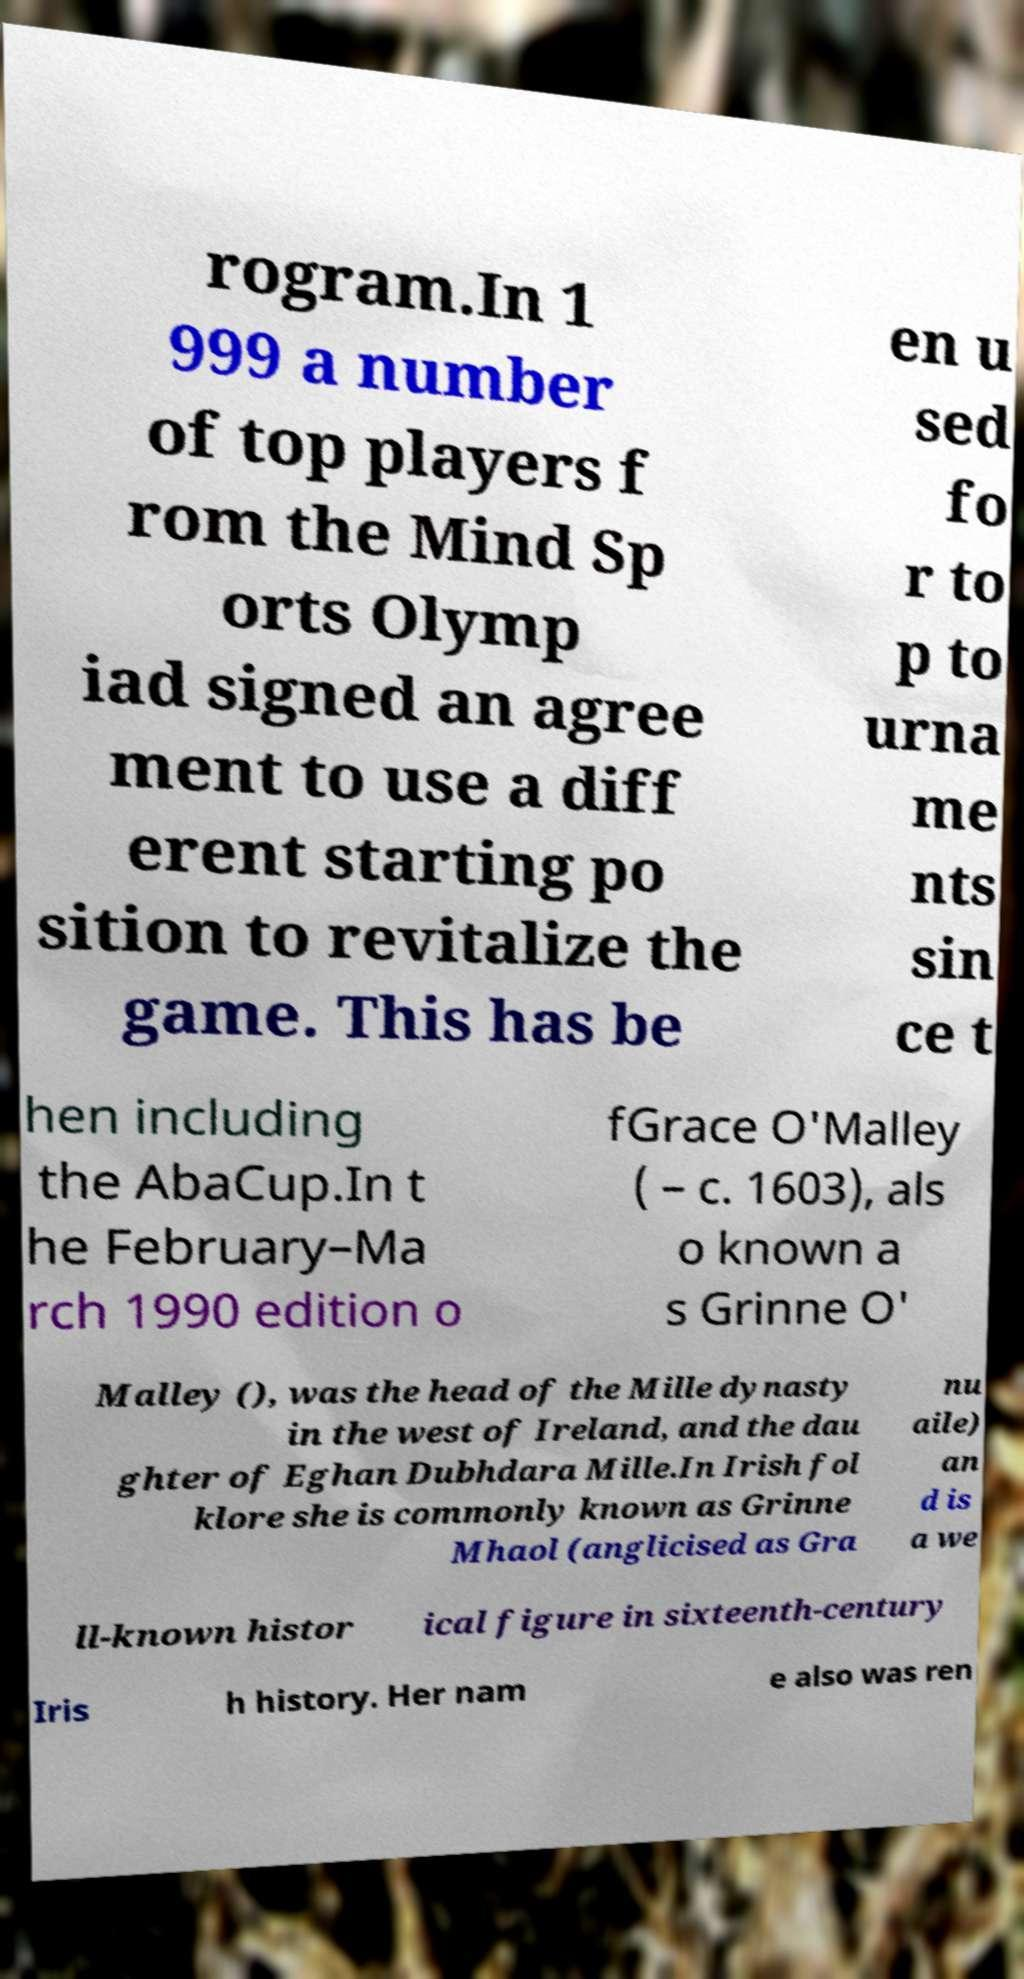I need the written content from this picture converted into text. Can you do that? rogram.In 1 999 a number of top players f rom the Mind Sp orts Olymp iad signed an agree ment to use a diff erent starting po sition to revitalize the game. This has be en u sed fo r to p to urna me nts sin ce t hen including the AbaCup.In t he February–Ma rch 1990 edition o fGrace O'Malley ( – c. 1603), als o known a s Grinne O' Malley (), was the head of the Mille dynasty in the west of Ireland, and the dau ghter of Eghan Dubhdara Mille.In Irish fol klore she is commonly known as Grinne Mhaol (anglicised as Gra nu aile) an d is a we ll-known histor ical figure in sixteenth-century Iris h history. Her nam e also was ren 